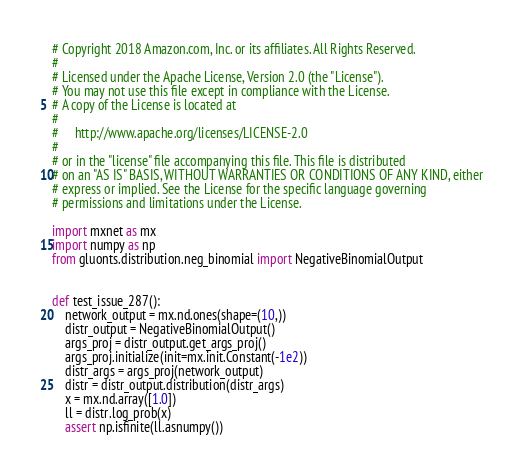<code> <loc_0><loc_0><loc_500><loc_500><_Python_># Copyright 2018 Amazon.com, Inc. or its affiliates. All Rights Reserved.
#
# Licensed under the Apache License, Version 2.0 (the "License").
# You may not use this file except in compliance with the License.
# A copy of the License is located at
#
#     http://www.apache.org/licenses/LICENSE-2.0
#
# or in the "license" file accompanying this file. This file is distributed
# on an "AS IS" BASIS, WITHOUT WARRANTIES OR CONDITIONS OF ANY KIND, either
# express or implied. See the License for the specific language governing
# permissions and limitations under the License.

import mxnet as mx
import numpy as np
from gluonts.distribution.neg_binomial import NegativeBinomialOutput


def test_issue_287():
    network_output = mx.nd.ones(shape=(10,))
    distr_output = NegativeBinomialOutput()
    args_proj = distr_output.get_args_proj()
    args_proj.initialize(init=mx.init.Constant(-1e2))
    distr_args = args_proj(network_output)
    distr = distr_output.distribution(distr_args)
    x = mx.nd.array([1.0])
    ll = distr.log_prob(x)
    assert np.isfinite(ll.asnumpy())
</code> 